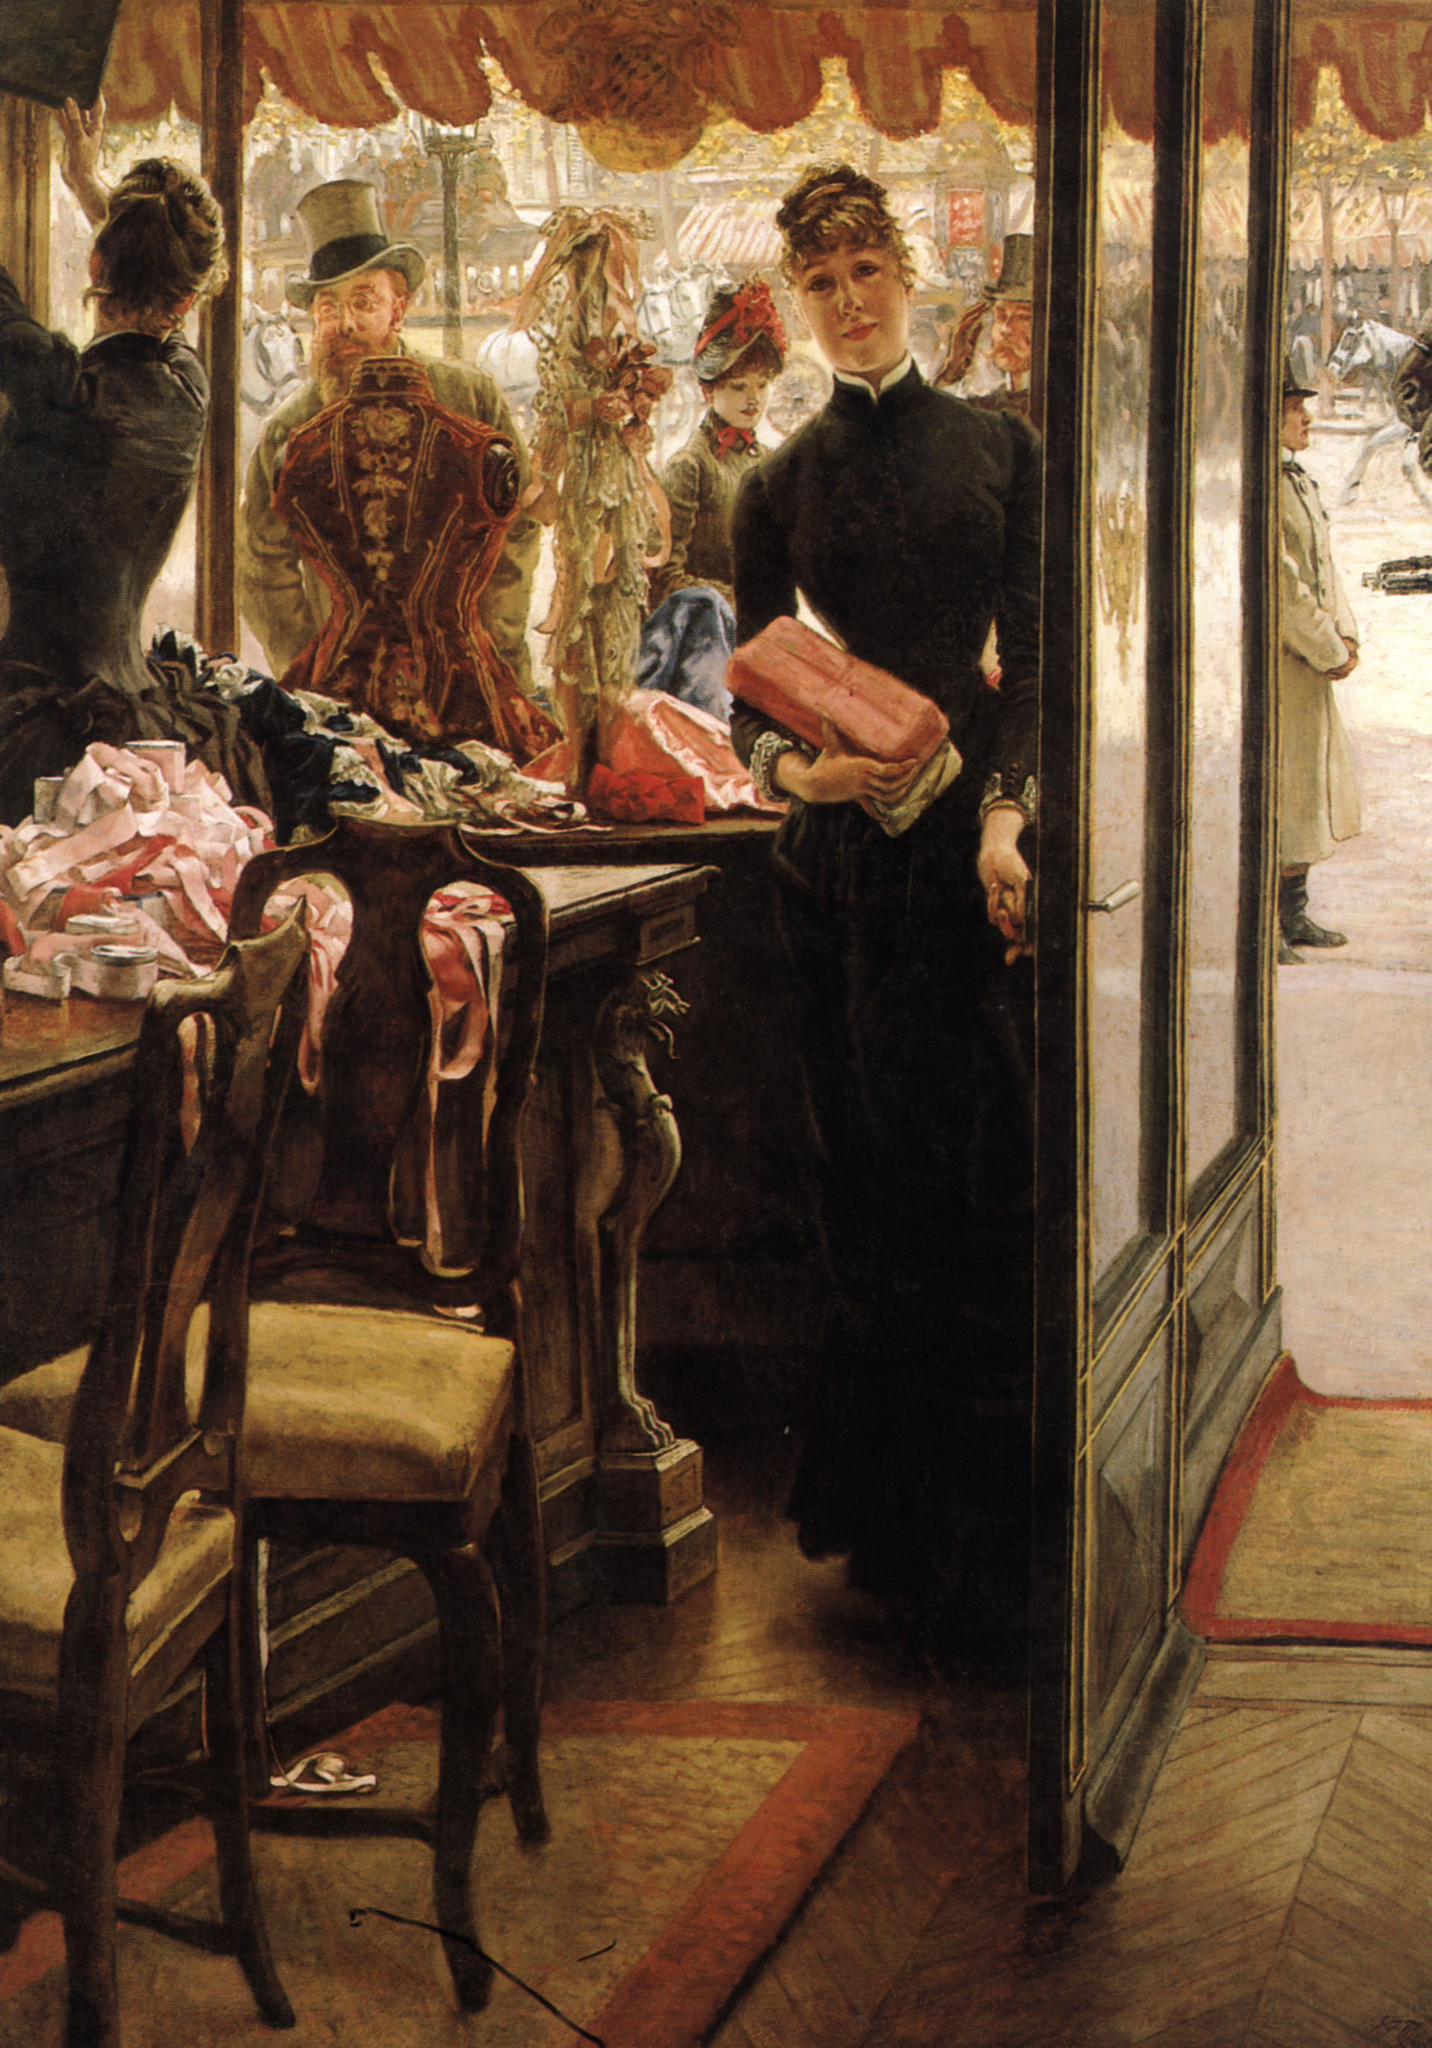Can you elaborate on the elements of the picture provided? The image is an exquisite oil painting titled "The Shop Girl" by James Tissot, created in the late 19th century. Captured in a realist style, it portrays a scene with an impeccable level of detail and accuracy. At the center is a young woman, dressed in a striking black dress, standing gracefully in a shop brimming with delicate items such as hats adorned with ribbons, lace, and elegant garments. She holds a vibrant pink scarf, her gaze contemplative, looking beyond the window onto a lively, bustling street. The warm, inviting tones of the shop's interior contrast sharply with her dark attire, making her the focal point. This painting not only showcases the rich textures and strengths of realist art but also provides poignant insight into the societal and economic nuances of the era, subtly highlighting the role and experience of women at the time. 